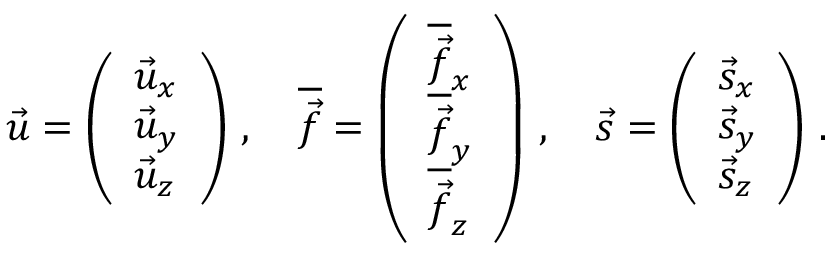<formula> <loc_0><loc_0><loc_500><loc_500>\vec { u } = \left ( \begin{array} { l } { \vec { u } _ { x } } \\ { \vec { u } _ { y } } \\ { \vec { u } _ { z } } \end{array} \right ) \, , \quad \overline { { \vec { f } } } = \left ( \begin{array} { l } { \overline { { \vec { f } } } _ { x } } \\ { \overline { { \vec { f } } } _ { y } } \\ { \overline { { \vec { f } } } _ { z } } \end{array} \right ) \, , \quad \vec { s } = \left ( \begin{array} { l } { \vec { s } _ { x } } \\ { \vec { s } _ { y } } \\ { \vec { s } _ { z } } \end{array} \right ) \, .</formula> 